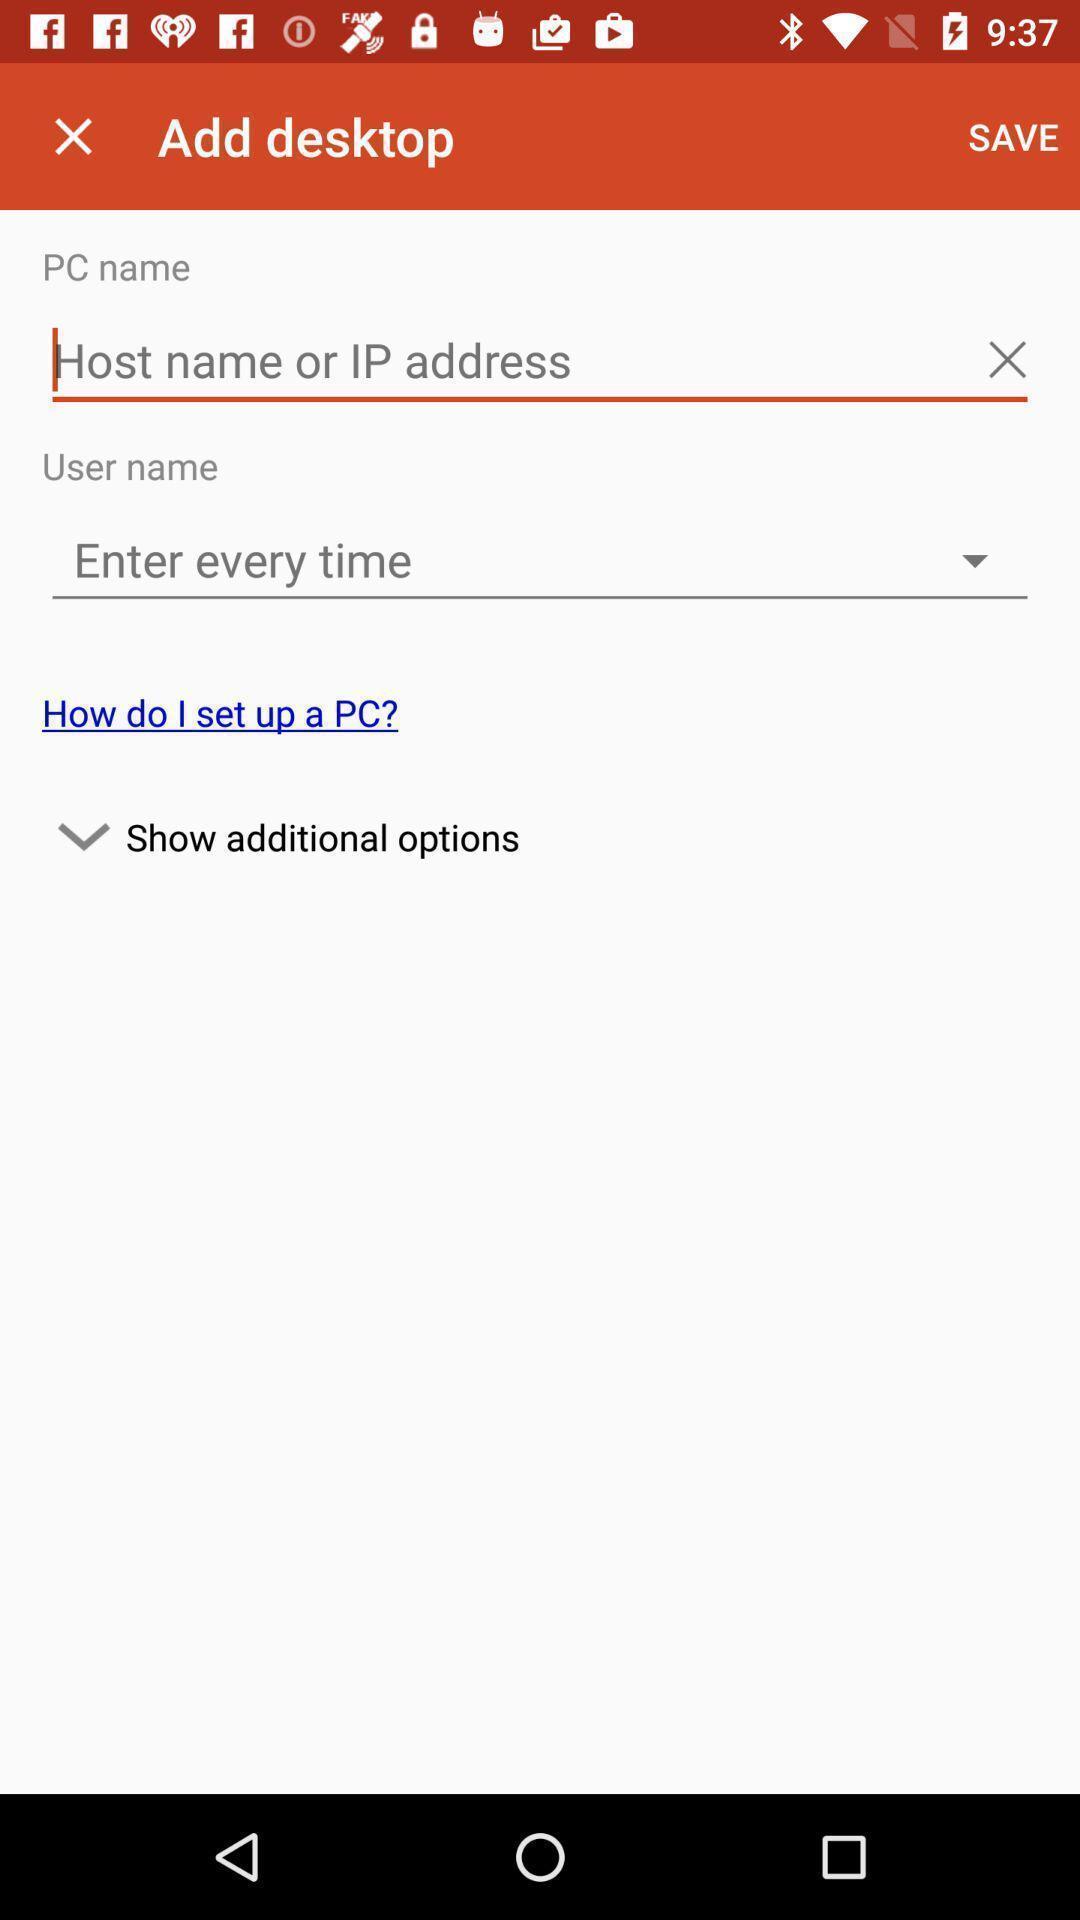Describe the content in this image. Screen showing add desktop option. 